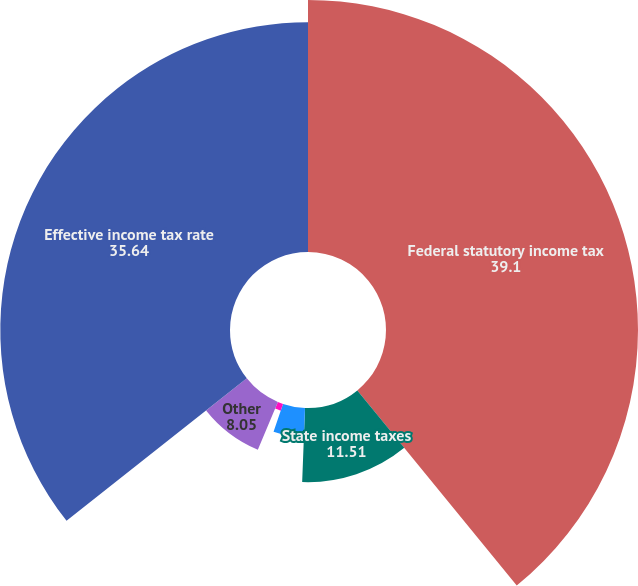Convert chart. <chart><loc_0><loc_0><loc_500><loc_500><pie_chart><fcel>Federal statutory income tax<fcel>State income taxes<fcel>Federal benefit of state taxes<fcel>Foreign rate differential<fcel>Other<fcel>Effective income tax rate<nl><fcel>39.1%<fcel>11.51%<fcel>4.58%<fcel>1.12%<fcel>8.05%<fcel>35.64%<nl></chart> 